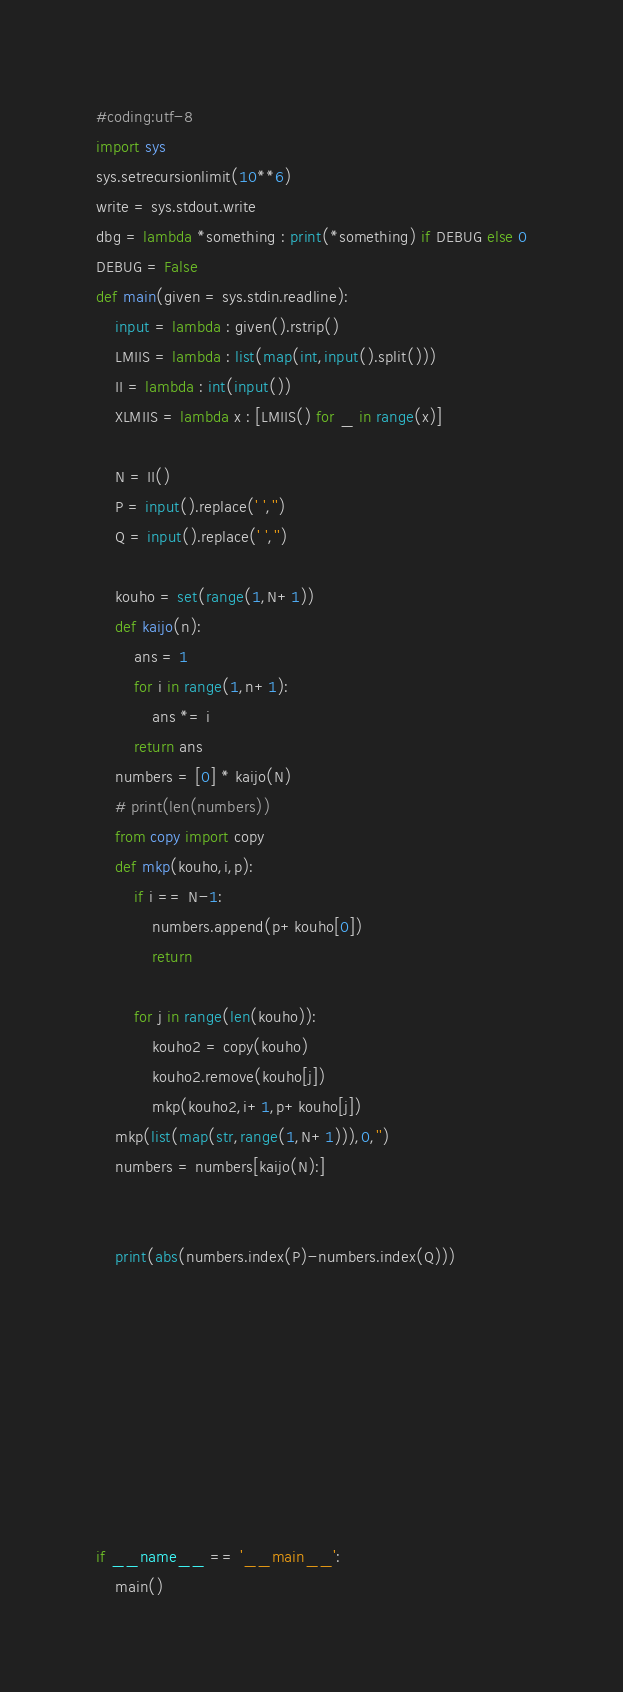Convert code to text. <code><loc_0><loc_0><loc_500><loc_500><_Python_>#coding:utf-8
import sys
sys.setrecursionlimit(10**6)
write = sys.stdout.write
dbg = lambda *something : print(*something) if DEBUG else 0
DEBUG = False
def main(given = sys.stdin.readline):
    input = lambda : given().rstrip()
    LMIIS = lambda : list(map(int,input().split()))
    II = lambda : int(input())
    XLMIIS = lambda x : [LMIIS() for _ in range(x)]

    N = II()
    P = input().replace(' ','')
    Q = input().replace(' ','')

    kouho = set(range(1,N+1))
    def kaijo(n):
        ans = 1
        for i in range(1,n+1):
            ans *= i
        return ans
    numbers = [0] * kaijo(N)
    # print(len(numbers))
    from copy import copy
    def mkp(kouho,i,p):
        if i == N-1:
            numbers.append(p+kouho[0])
            return

        for j in range(len(kouho)):
            kouho2 = copy(kouho)
            kouho2.remove(kouho[j])
            mkp(kouho2,i+1,p+kouho[j])
    mkp(list(map(str,range(1,N+1))),0,'')
    numbers = numbers[kaijo(N):]


    print(abs(numbers.index(P)-numbers.index(Q)))
    



   




if __name__ == '__main__':
    main()</code> 